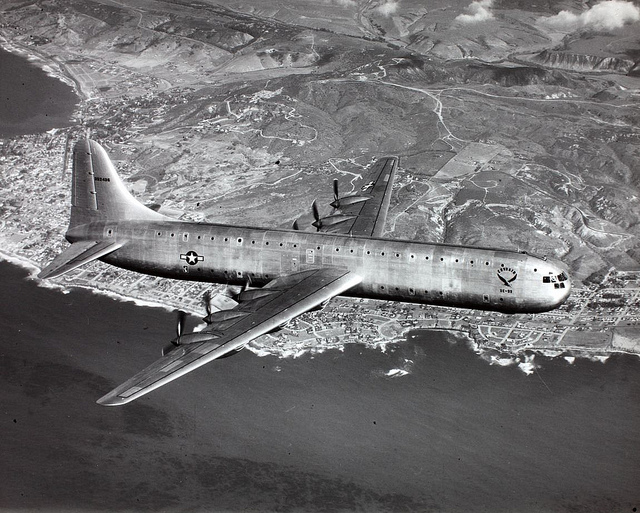<image>How high up is the airplane? It is unknown how high up the airplane is. How high up is the airplane? I don't know how high up the airplane is. It can be anywhere between 25000 ft to not very high. 